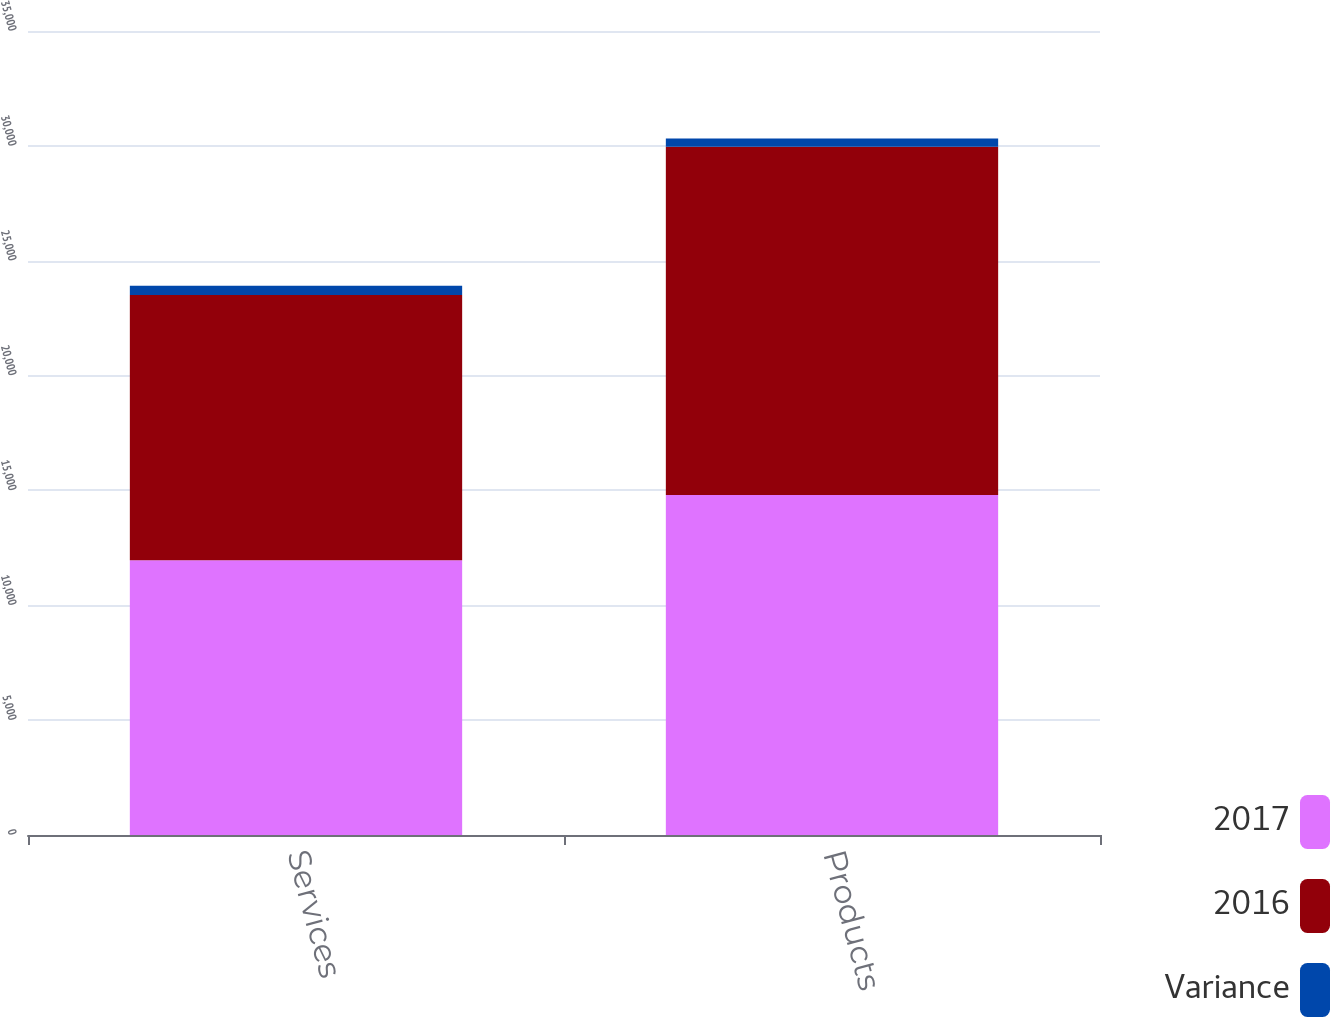<chart> <loc_0><loc_0><loc_500><loc_500><stacked_bar_chart><ecel><fcel>Services<fcel>Products<nl><fcel>2017<fcel>11957<fcel>14799<nl><fcel>2016<fcel>11551<fcel>15159<nl><fcel>Variance<fcel>406<fcel>360<nl></chart> 